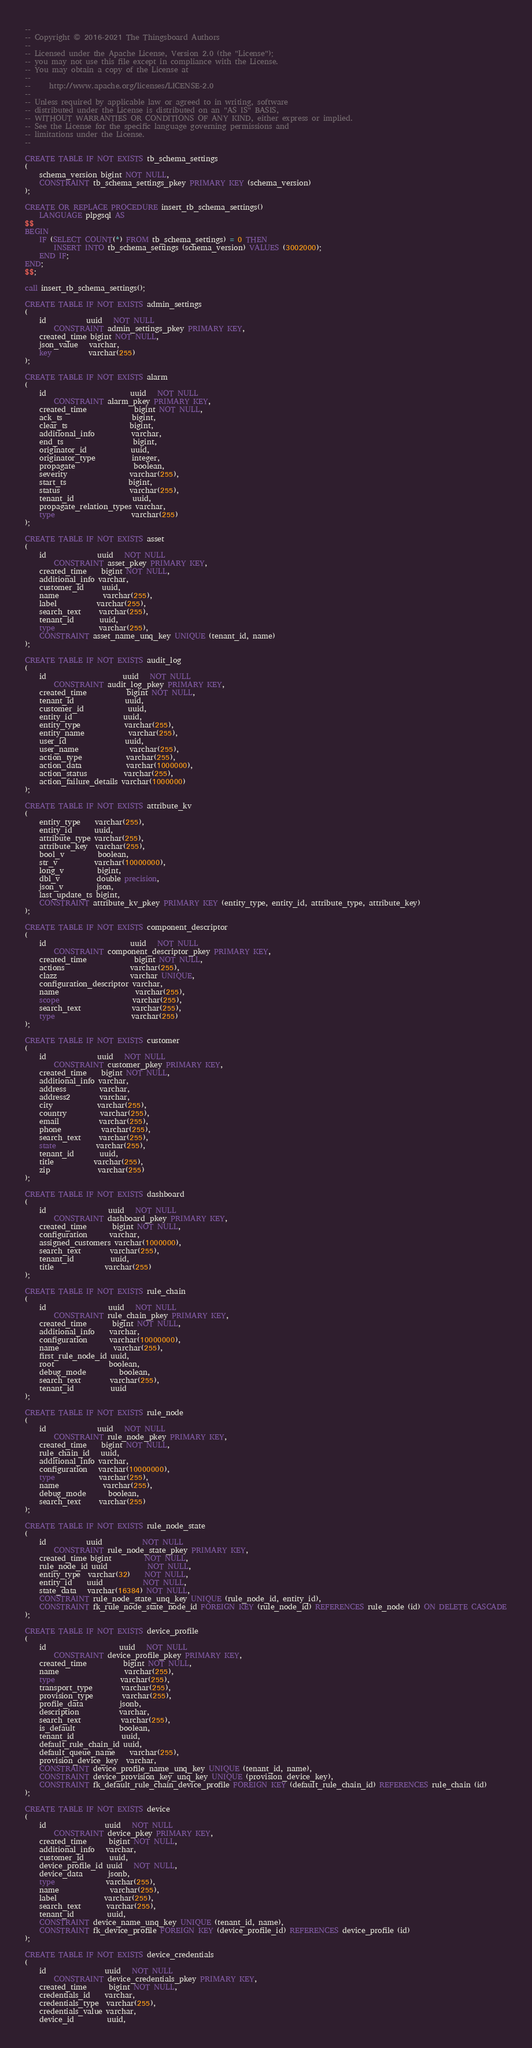<code> <loc_0><loc_0><loc_500><loc_500><_SQL_>--
-- Copyright © 2016-2021 The Thingsboard Authors
--
-- Licensed under the Apache License, Version 2.0 (the "License");
-- you may not use this file except in compliance with the License.
-- You may obtain a copy of the License at
--
--     http://www.apache.org/licenses/LICENSE-2.0
--
-- Unless required by applicable law or agreed to in writing, software
-- distributed under the License is distributed on an "AS IS" BASIS,
-- WITHOUT WARRANTIES OR CONDITIONS OF ANY KIND, either express or implied.
-- See the License for the specific language governing permissions and
-- limitations under the License.
--

CREATE TABLE IF NOT EXISTS tb_schema_settings
(
    schema_version bigint NOT NULL,
    CONSTRAINT tb_schema_settings_pkey PRIMARY KEY (schema_version)
);

CREATE OR REPLACE PROCEDURE insert_tb_schema_settings()
    LANGUAGE plpgsql AS
$$
BEGIN
    IF (SELECT COUNT(*) FROM tb_schema_settings) = 0 THEN
        INSERT INTO tb_schema_settings (schema_version) VALUES (3002000);
    END IF;
END;
$$;

call insert_tb_schema_settings();

CREATE TABLE IF NOT EXISTS admin_settings
(
    id           uuid   NOT NULL
        CONSTRAINT admin_settings_pkey PRIMARY KEY,
    created_time bigint NOT NULL,
    json_value   varchar,
    key          varchar(255)
);

CREATE TABLE IF NOT EXISTS alarm
(
    id                       uuid   NOT NULL
        CONSTRAINT alarm_pkey PRIMARY KEY,
    created_time             bigint NOT NULL,
    ack_ts                   bigint,
    clear_ts                 bigint,
    additional_info          varchar,
    end_ts                   bigint,
    originator_id            uuid,
    originator_type          integer,
    propagate                boolean,
    severity                 varchar(255),
    start_ts                 bigint,
    status                   varchar(255),
    tenant_id                uuid,
    propagate_relation_types varchar,
    type                     varchar(255)
);

CREATE TABLE IF NOT EXISTS asset
(
    id              uuid   NOT NULL
        CONSTRAINT asset_pkey PRIMARY KEY,
    created_time    bigint NOT NULL,
    additional_info varchar,
    customer_id     uuid,
    name            varchar(255),
    label           varchar(255),
    search_text     varchar(255),
    tenant_id       uuid,
    type            varchar(255),
    CONSTRAINT asset_name_unq_key UNIQUE (tenant_id, name)
);

CREATE TABLE IF NOT EXISTS audit_log
(
    id                     uuid   NOT NULL
        CONSTRAINT audit_log_pkey PRIMARY KEY,
    created_time           bigint NOT NULL,
    tenant_id              uuid,
    customer_id            uuid,
    entity_id              uuid,
    entity_type            varchar(255),
    entity_name            varchar(255),
    user_id                uuid,
    user_name              varchar(255),
    action_type            varchar(255),
    action_data            varchar(1000000),
    action_status          varchar(255),
    action_failure_details varchar(1000000)
);

CREATE TABLE IF NOT EXISTS attribute_kv
(
    entity_type    varchar(255),
    entity_id      uuid,
    attribute_type varchar(255),
    attribute_key  varchar(255),
    bool_v         boolean,
    str_v          varchar(10000000),
    long_v         bigint,
    dbl_v          double precision,
    json_v         json,
    last_update_ts bigint,
    CONSTRAINT attribute_kv_pkey PRIMARY KEY (entity_type, entity_id, attribute_type, attribute_key)
);

CREATE TABLE IF NOT EXISTS component_descriptor
(
    id                       uuid   NOT NULL
        CONSTRAINT component_descriptor_pkey PRIMARY KEY,
    created_time             bigint NOT NULL,
    actions                  varchar(255),
    clazz                    varchar UNIQUE,
    configuration_descriptor varchar,
    name                     varchar(255),
    scope                    varchar(255),
    search_text              varchar(255),
    type                     varchar(255)
);

CREATE TABLE IF NOT EXISTS customer
(
    id              uuid   NOT NULL
        CONSTRAINT customer_pkey PRIMARY KEY,
    created_time    bigint NOT NULL,
    additional_info varchar,
    address         varchar,
    address2        varchar,
    city            varchar(255),
    country         varchar(255),
    email           varchar(255),
    phone           varchar(255),
    search_text     varchar(255),
    state           varchar(255),
    tenant_id       uuid,
    title           varchar(255),
    zip             varchar(255)
);

CREATE TABLE IF NOT EXISTS dashboard
(
    id                 uuid   NOT NULL
        CONSTRAINT dashboard_pkey PRIMARY KEY,
    created_time       bigint NOT NULL,
    configuration      varchar,
    assigned_customers varchar(1000000),
    search_text        varchar(255),
    tenant_id          uuid,
    title              varchar(255)
);

CREATE TABLE IF NOT EXISTS rule_chain
(
    id                 uuid   NOT NULL
        CONSTRAINT rule_chain_pkey PRIMARY KEY,
    created_time       bigint NOT NULL,
    additional_info    varchar,
    configuration      varchar(10000000),
    name               varchar(255),
    first_rule_node_id uuid,
    root               boolean,
    debug_mode         boolean,
    search_text        varchar(255),
    tenant_id          uuid
);

CREATE TABLE IF NOT EXISTS rule_node
(
    id              uuid   NOT NULL
        CONSTRAINT rule_node_pkey PRIMARY KEY,
    created_time    bigint NOT NULL,
    rule_chain_id   uuid,
    additional_info varchar,
    configuration   varchar(10000000),
    type            varchar(255),
    name            varchar(255),
    debug_mode      boolean,
    search_text     varchar(255)
);

CREATE TABLE IF NOT EXISTS rule_node_state
(
    id           uuid           NOT NULL
        CONSTRAINT rule_node_state_pkey PRIMARY KEY,
    created_time bigint         NOT NULL,
    rule_node_id uuid           NOT NULL,
    entity_type  varchar(32)    NOT NULL,
    entity_id    uuid           NOT NULL,
    state_data   varchar(16384) NOT NULL,
    CONSTRAINT rule_node_state_unq_key UNIQUE (rule_node_id, entity_id),
    CONSTRAINT fk_rule_node_state_node_id FOREIGN KEY (rule_node_id) REFERENCES rule_node (id) ON DELETE CASCADE
);

CREATE TABLE IF NOT EXISTS device_profile
(
    id                    uuid   NOT NULL
        CONSTRAINT device_profile_pkey PRIMARY KEY,
    created_time          bigint NOT NULL,
    name                  varchar(255),
    type                  varchar(255),
    transport_type        varchar(255),
    provision_type        varchar(255),
    profile_data          jsonb,
    description           varchar,
    search_text           varchar(255),
    is_default            boolean,
    tenant_id             uuid,
    default_rule_chain_id uuid,
    default_queue_name    varchar(255),
    provision_device_key  varchar,
    CONSTRAINT device_profile_name_unq_key UNIQUE (tenant_id, name),
    CONSTRAINT device_provision_key_unq_key UNIQUE (provision_device_key),
    CONSTRAINT fk_default_rule_chain_device_profile FOREIGN KEY (default_rule_chain_id) REFERENCES rule_chain (id)
);

CREATE TABLE IF NOT EXISTS device
(
    id                uuid   NOT NULL
        CONSTRAINT device_pkey PRIMARY KEY,
    created_time      bigint NOT NULL,
    additional_info   varchar,
    customer_id       uuid,
    device_profile_id uuid   NOT NULL,
    device_data       jsonb,
    type              varchar(255),
    name              varchar(255),
    label             varchar(255),
    search_text       varchar(255),
    tenant_id         uuid,
    CONSTRAINT device_name_unq_key UNIQUE (tenant_id, name),
    CONSTRAINT fk_device_profile FOREIGN KEY (device_profile_id) REFERENCES device_profile (id)
);

CREATE TABLE IF NOT EXISTS device_credentials
(
    id                uuid   NOT NULL
        CONSTRAINT device_credentials_pkey PRIMARY KEY,
    created_time      bigint NOT NULL,
    credentials_id    varchar,
    credentials_type  varchar(255),
    credentials_value varchar,
    device_id         uuid,</code> 